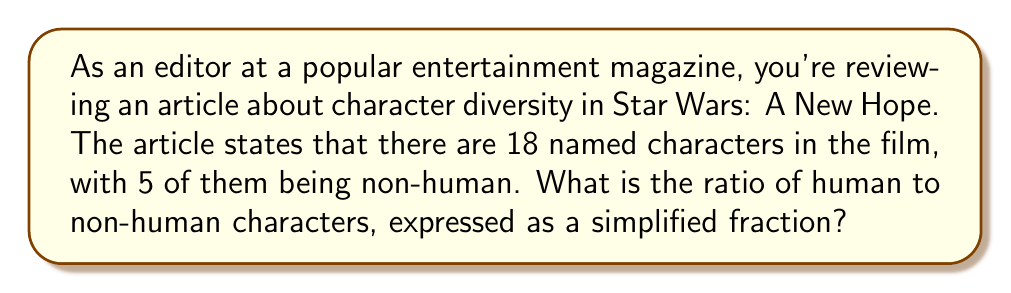Could you help me with this problem? To solve this problem, we need to follow these steps:

1. Identify the number of human characters:
   Total characters = 18
   Non-human characters = 5
   Human characters = 18 - 5 = 13

2. Set up the ratio of human to non-human characters:
   $\frac{\text{Human characters}}{\text{Non-human characters}} = \frac{13}{5}$

3. This ratio is already in its simplest form, as 13 and 5 have no common factors other than 1.

The ratio $\frac{13}{5}$ represents that for every 13 human characters, there are 5 non-human characters in Star Wars: A New Hope.
Answer: $\frac{13}{5}$ 